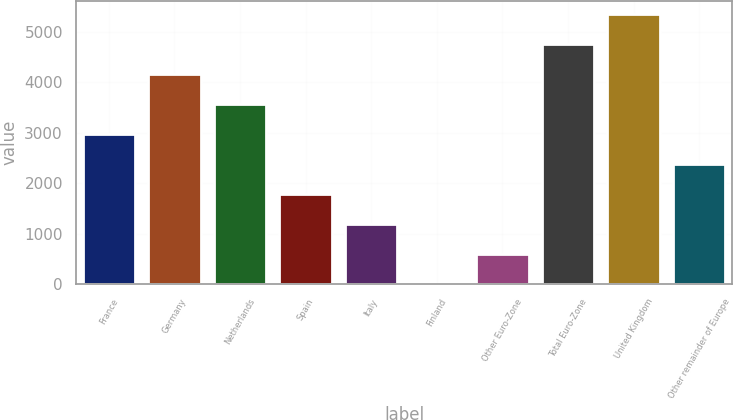<chart> <loc_0><loc_0><loc_500><loc_500><bar_chart><fcel>France<fcel>Germany<fcel>Netherlands<fcel>Spain<fcel>Italy<fcel>Finland<fcel>Other Euro-Zone<fcel>Total Euro-Zone<fcel>United Kingdom<fcel>Other remainder of Europe<nl><fcel>2969.5<fcel>4156.9<fcel>3563.2<fcel>1782.1<fcel>1188.4<fcel>1<fcel>594.7<fcel>4750.6<fcel>5344.3<fcel>2375.8<nl></chart> 